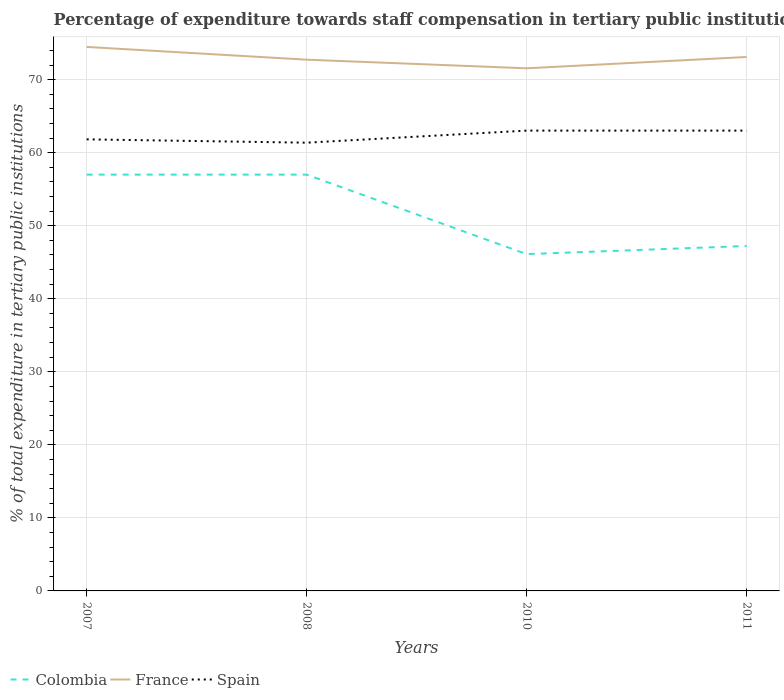How many different coloured lines are there?
Ensure brevity in your answer.  3. Across all years, what is the maximum percentage of expenditure towards staff compensation in Colombia?
Your answer should be compact. 46.12. In which year was the percentage of expenditure towards staff compensation in Colombia maximum?
Give a very brief answer. 2010. What is the total percentage of expenditure towards staff compensation in France in the graph?
Give a very brief answer. 1.74. What is the difference between the highest and the second highest percentage of expenditure towards staff compensation in Spain?
Provide a succinct answer. 1.65. What is the difference between the highest and the lowest percentage of expenditure towards staff compensation in Colombia?
Give a very brief answer. 2. How many years are there in the graph?
Your answer should be compact. 4. What is the difference between two consecutive major ticks on the Y-axis?
Provide a short and direct response. 10. Are the values on the major ticks of Y-axis written in scientific E-notation?
Offer a terse response. No. Does the graph contain grids?
Your answer should be very brief. Yes. Where does the legend appear in the graph?
Your response must be concise. Bottom left. What is the title of the graph?
Make the answer very short. Percentage of expenditure towards staff compensation in tertiary public institutions. Does "Nicaragua" appear as one of the legend labels in the graph?
Offer a terse response. No. What is the label or title of the X-axis?
Your answer should be compact. Years. What is the label or title of the Y-axis?
Offer a very short reply. % of total expenditure in tertiary public institutions. What is the % of total expenditure in tertiary public institutions in Colombia in 2007?
Ensure brevity in your answer.  57. What is the % of total expenditure in tertiary public institutions of France in 2007?
Offer a terse response. 74.48. What is the % of total expenditure in tertiary public institutions in Spain in 2007?
Your response must be concise. 61.83. What is the % of total expenditure in tertiary public institutions in Colombia in 2008?
Keep it short and to the point. 57. What is the % of total expenditure in tertiary public institutions of France in 2008?
Offer a very short reply. 72.74. What is the % of total expenditure in tertiary public institutions in Spain in 2008?
Your response must be concise. 61.37. What is the % of total expenditure in tertiary public institutions in Colombia in 2010?
Provide a succinct answer. 46.12. What is the % of total expenditure in tertiary public institutions in France in 2010?
Your answer should be compact. 71.56. What is the % of total expenditure in tertiary public institutions of Spain in 2010?
Offer a terse response. 63.03. What is the % of total expenditure in tertiary public institutions in Colombia in 2011?
Your answer should be compact. 47.23. What is the % of total expenditure in tertiary public institutions of France in 2011?
Your answer should be compact. 73.1. What is the % of total expenditure in tertiary public institutions of Spain in 2011?
Offer a terse response. 63.03. Across all years, what is the maximum % of total expenditure in tertiary public institutions in Colombia?
Keep it short and to the point. 57. Across all years, what is the maximum % of total expenditure in tertiary public institutions in France?
Offer a terse response. 74.48. Across all years, what is the maximum % of total expenditure in tertiary public institutions of Spain?
Ensure brevity in your answer.  63.03. Across all years, what is the minimum % of total expenditure in tertiary public institutions of Colombia?
Keep it short and to the point. 46.12. Across all years, what is the minimum % of total expenditure in tertiary public institutions in France?
Provide a short and direct response. 71.56. Across all years, what is the minimum % of total expenditure in tertiary public institutions of Spain?
Keep it short and to the point. 61.37. What is the total % of total expenditure in tertiary public institutions of Colombia in the graph?
Provide a short and direct response. 207.34. What is the total % of total expenditure in tertiary public institutions in France in the graph?
Make the answer very short. 291.88. What is the total % of total expenditure in tertiary public institutions of Spain in the graph?
Offer a very short reply. 249.25. What is the difference between the % of total expenditure in tertiary public institutions of France in 2007 and that in 2008?
Offer a very short reply. 1.74. What is the difference between the % of total expenditure in tertiary public institutions in Spain in 2007 and that in 2008?
Your answer should be very brief. 0.46. What is the difference between the % of total expenditure in tertiary public institutions of Colombia in 2007 and that in 2010?
Your answer should be very brief. 10.88. What is the difference between the % of total expenditure in tertiary public institutions in France in 2007 and that in 2010?
Ensure brevity in your answer.  2.93. What is the difference between the % of total expenditure in tertiary public institutions in Spain in 2007 and that in 2010?
Provide a succinct answer. -1.2. What is the difference between the % of total expenditure in tertiary public institutions in Colombia in 2007 and that in 2011?
Ensure brevity in your answer.  9.77. What is the difference between the % of total expenditure in tertiary public institutions of France in 2007 and that in 2011?
Give a very brief answer. 1.38. What is the difference between the % of total expenditure in tertiary public institutions of Spain in 2007 and that in 2011?
Your response must be concise. -1.2. What is the difference between the % of total expenditure in tertiary public institutions in Colombia in 2008 and that in 2010?
Keep it short and to the point. 10.88. What is the difference between the % of total expenditure in tertiary public institutions in France in 2008 and that in 2010?
Give a very brief answer. 1.18. What is the difference between the % of total expenditure in tertiary public institutions in Spain in 2008 and that in 2010?
Provide a short and direct response. -1.65. What is the difference between the % of total expenditure in tertiary public institutions in Colombia in 2008 and that in 2011?
Provide a succinct answer. 9.77. What is the difference between the % of total expenditure in tertiary public institutions in France in 2008 and that in 2011?
Provide a succinct answer. -0.37. What is the difference between the % of total expenditure in tertiary public institutions in Spain in 2008 and that in 2011?
Keep it short and to the point. -1.65. What is the difference between the % of total expenditure in tertiary public institutions of Colombia in 2010 and that in 2011?
Your answer should be very brief. -1.11. What is the difference between the % of total expenditure in tertiary public institutions of France in 2010 and that in 2011?
Offer a terse response. -1.55. What is the difference between the % of total expenditure in tertiary public institutions of Colombia in 2007 and the % of total expenditure in tertiary public institutions of France in 2008?
Provide a short and direct response. -15.74. What is the difference between the % of total expenditure in tertiary public institutions in Colombia in 2007 and the % of total expenditure in tertiary public institutions in Spain in 2008?
Offer a very short reply. -4.37. What is the difference between the % of total expenditure in tertiary public institutions of France in 2007 and the % of total expenditure in tertiary public institutions of Spain in 2008?
Your answer should be very brief. 13.11. What is the difference between the % of total expenditure in tertiary public institutions in Colombia in 2007 and the % of total expenditure in tertiary public institutions in France in 2010?
Your response must be concise. -14.56. What is the difference between the % of total expenditure in tertiary public institutions of Colombia in 2007 and the % of total expenditure in tertiary public institutions of Spain in 2010?
Your answer should be very brief. -6.03. What is the difference between the % of total expenditure in tertiary public institutions in France in 2007 and the % of total expenditure in tertiary public institutions in Spain in 2010?
Ensure brevity in your answer.  11.46. What is the difference between the % of total expenditure in tertiary public institutions in Colombia in 2007 and the % of total expenditure in tertiary public institutions in France in 2011?
Offer a terse response. -16.11. What is the difference between the % of total expenditure in tertiary public institutions of Colombia in 2007 and the % of total expenditure in tertiary public institutions of Spain in 2011?
Your response must be concise. -6.03. What is the difference between the % of total expenditure in tertiary public institutions in France in 2007 and the % of total expenditure in tertiary public institutions in Spain in 2011?
Offer a terse response. 11.46. What is the difference between the % of total expenditure in tertiary public institutions of Colombia in 2008 and the % of total expenditure in tertiary public institutions of France in 2010?
Offer a very short reply. -14.56. What is the difference between the % of total expenditure in tertiary public institutions in Colombia in 2008 and the % of total expenditure in tertiary public institutions in Spain in 2010?
Keep it short and to the point. -6.03. What is the difference between the % of total expenditure in tertiary public institutions in France in 2008 and the % of total expenditure in tertiary public institutions in Spain in 2010?
Provide a short and direct response. 9.71. What is the difference between the % of total expenditure in tertiary public institutions of Colombia in 2008 and the % of total expenditure in tertiary public institutions of France in 2011?
Keep it short and to the point. -16.11. What is the difference between the % of total expenditure in tertiary public institutions of Colombia in 2008 and the % of total expenditure in tertiary public institutions of Spain in 2011?
Your response must be concise. -6.03. What is the difference between the % of total expenditure in tertiary public institutions in France in 2008 and the % of total expenditure in tertiary public institutions in Spain in 2011?
Give a very brief answer. 9.71. What is the difference between the % of total expenditure in tertiary public institutions of Colombia in 2010 and the % of total expenditure in tertiary public institutions of France in 2011?
Give a very brief answer. -26.99. What is the difference between the % of total expenditure in tertiary public institutions in Colombia in 2010 and the % of total expenditure in tertiary public institutions in Spain in 2011?
Provide a succinct answer. -16.91. What is the difference between the % of total expenditure in tertiary public institutions of France in 2010 and the % of total expenditure in tertiary public institutions of Spain in 2011?
Your answer should be compact. 8.53. What is the average % of total expenditure in tertiary public institutions of Colombia per year?
Keep it short and to the point. 51.83. What is the average % of total expenditure in tertiary public institutions in France per year?
Provide a short and direct response. 72.97. What is the average % of total expenditure in tertiary public institutions in Spain per year?
Provide a succinct answer. 62.31. In the year 2007, what is the difference between the % of total expenditure in tertiary public institutions of Colombia and % of total expenditure in tertiary public institutions of France?
Offer a terse response. -17.48. In the year 2007, what is the difference between the % of total expenditure in tertiary public institutions of Colombia and % of total expenditure in tertiary public institutions of Spain?
Your response must be concise. -4.83. In the year 2007, what is the difference between the % of total expenditure in tertiary public institutions in France and % of total expenditure in tertiary public institutions in Spain?
Give a very brief answer. 12.65. In the year 2008, what is the difference between the % of total expenditure in tertiary public institutions in Colombia and % of total expenditure in tertiary public institutions in France?
Offer a very short reply. -15.74. In the year 2008, what is the difference between the % of total expenditure in tertiary public institutions in Colombia and % of total expenditure in tertiary public institutions in Spain?
Provide a short and direct response. -4.37. In the year 2008, what is the difference between the % of total expenditure in tertiary public institutions of France and % of total expenditure in tertiary public institutions of Spain?
Your answer should be compact. 11.37. In the year 2010, what is the difference between the % of total expenditure in tertiary public institutions of Colombia and % of total expenditure in tertiary public institutions of France?
Keep it short and to the point. -25.44. In the year 2010, what is the difference between the % of total expenditure in tertiary public institutions of Colombia and % of total expenditure in tertiary public institutions of Spain?
Your answer should be compact. -16.91. In the year 2010, what is the difference between the % of total expenditure in tertiary public institutions in France and % of total expenditure in tertiary public institutions in Spain?
Your answer should be compact. 8.53. In the year 2011, what is the difference between the % of total expenditure in tertiary public institutions of Colombia and % of total expenditure in tertiary public institutions of France?
Offer a very short reply. -25.88. In the year 2011, what is the difference between the % of total expenditure in tertiary public institutions in Colombia and % of total expenditure in tertiary public institutions in Spain?
Offer a very short reply. -15.8. In the year 2011, what is the difference between the % of total expenditure in tertiary public institutions in France and % of total expenditure in tertiary public institutions in Spain?
Provide a short and direct response. 10.08. What is the ratio of the % of total expenditure in tertiary public institutions of Spain in 2007 to that in 2008?
Ensure brevity in your answer.  1.01. What is the ratio of the % of total expenditure in tertiary public institutions of Colombia in 2007 to that in 2010?
Give a very brief answer. 1.24. What is the ratio of the % of total expenditure in tertiary public institutions in France in 2007 to that in 2010?
Make the answer very short. 1.04. What is the ratio of the % of total expenditure in tertiary public institutions in Colombia in 2007 to that in 2011?
Your response must be concise. 1.21. What is the ratio of the % of total expenditure in tertiary public institutions in France in 2007 to that in 2011?
Make the answer very short. 1.02. What is the ratio of the % of total expenditure in tertiary public institutions of Colombia in 2008 to that in 2010?
Provide a short and direct response. 1.24. What is the ratio of the % of total expenditure in tertiary public institutions of France in 2008 to that in 2010?
Ensure brevity in your answer.  1.02. What is the ratio of the % of total expenditure in tertiary public institutions in Spain in 2008 to that in 2010?
Provide a succinct answer. 0.97. What is the ratio of the % of total expenditure in tertiary public institutions in Colombia in 2008 to that in 2011?
Your answer should be compact. 1.21. What is the ratio of the % of total expenditure in tertiary public institutions in France in 2008 to that in 2011?
Your answer should be very brief. 0.99. What is the ratio of the % of total expenditure in tertiary public institutions in Spain in 2008 to that in 2011?
Give a very brief answer. 0.97. What is the ratio of the % of total expenditure in tertiary public institutions of Colombia in 2010 to that in 2011?
Your answer should be compact. 0.98. What is the ratio of the % of total expenditure in tertiary public institutions in France in 2010 to that in 2011?
Your answer should be compact. 0.98. What is the difference between the highest and the second highest % of total expenditure in tertiary public institutions in Colombia?
Your answer should be compact. 0. What is the difference between the highest and the second highest % of total expenditure in tertiary public institutions of France?
Your answer should be very brief. 1.38. What is the difference between the highest and the second highest % of total expenditure in tertiary public institutions of Spain?
Provide a short and direct response. 0. What is the difference between the highest and the lowest % of total expenditure in tertiary public institutions of Colombia?
Keep it short and to the point. 10.88. What is the difference between the highest and the lowest % of total expenditure in tertiary public institutions of France?
Your response must be concise. 2.93. What is the difference between the highest and the lowest % of total expenditure in tertiary public institutions in Spain?
Provide a short and direct response. 1.65. 